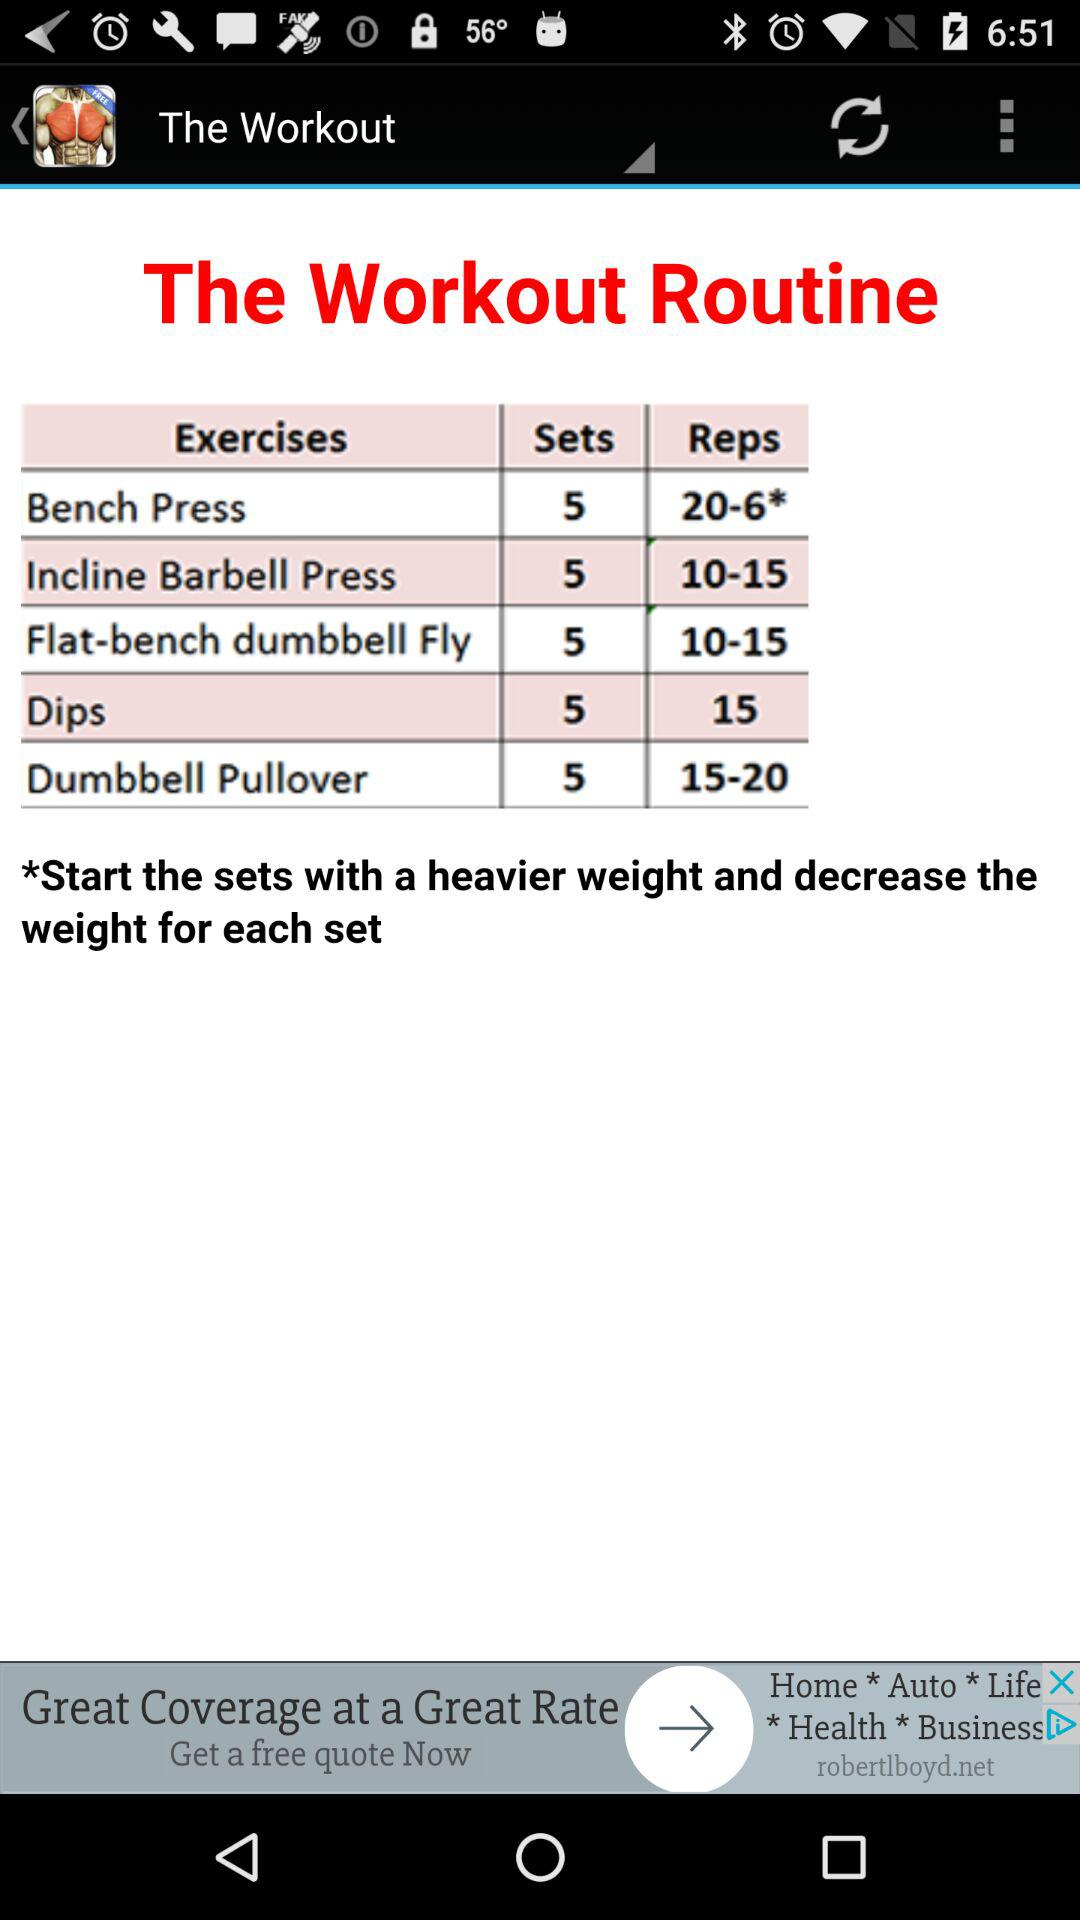Which exercise has a range of 15-20 reps? The exercise name is "Dumbbell Pullover". 